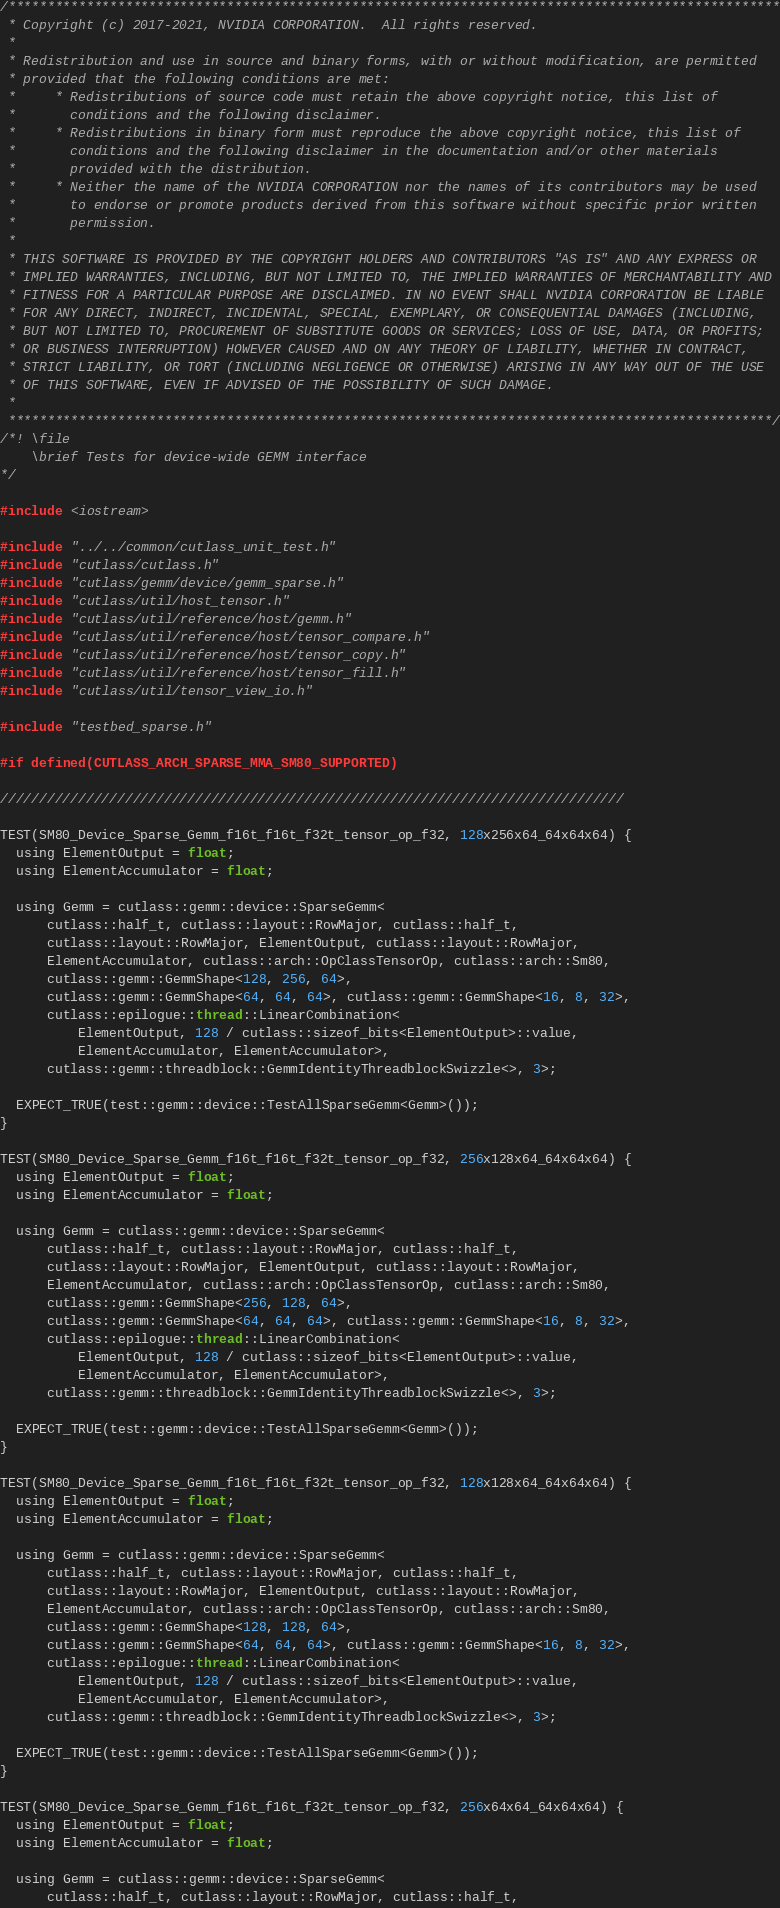Convert code to text. <code><loc_0><loc_0><loc_500><loc_500><_Cuda_>/***************************************************************************************************
 * Copyright (c) 2017-2021, NVIDIA CORPORATION.  All rights reserved.
 *
 * Redistribution and use in source and binary forms, with or without modification, are permitted
 * provided that the following conditions are met:
 *     * Redistributions of source code must retain the above copyright notice, this list of
 *       conditions and the following disclaimer.
 *     * Redistributions in binary form must reproduce the above copyright notice, this list of
 *       conditions and the following disclaimer in the documentation and/or other materials
 *       provided with the distribution.
 *     * Neither the name of the NVIDIA CORPORATION nor the names of its contributors may be used
 *       to endorse or promote products derived from this software without specific prior written
 *       permission.
 *
 * THIS SOFTWARE IS PROVIDED BY THE COPYRIGHT HOLDERS AND CONTRIBUTORS "AS IS" AND ANY EXPRESS OR
 * IMPLIED WARRANTIES, INCLUDING, BUT NOT LIMITED TO, THE IMPLIED WARRANTIES OF MERCHANTABILITY AND
 * FITNESS FOR A PARTICULAR PURPOSE ARE DISCLAIMED. IN NO EVENT SHALL NVIDIA CORPORATION BE LIABLE
 * FOR ANY DIRECT, INDIRECT, INCIDENTAL, SPECIAL, EXEMPLARY, OR CONSEQUENTIAL DAMAGES (INCLUDING,
 * BUT NOT LIMITED TO, PROCUREMENT OF SUBSTITUTE GOODS OR SERVICES; LOSS OF USE, DATA, OR PROFITS;
 * OR BUSINESS INTERRUPTION) HOWEVER CAUSED AND ON ANY THEORY OF LIABILITY, WHETHER IN CONTRACT,
 * STRICT LIABILITY, OR TORT (INCLUDING NEGLIGENCE OR OTHERWISE) ARISING IN ANY WAY OUT OF THE USE
 * OF THIS SOFTWARE, EVEN IF ADVISED OF THE POSSIBILITY OF SUCH DAMAGE.
 *
 **************************************************************************************************/
/*! \file
    \brief Tests for device-wide GEMM interface
*/

#include <iostream>

#include "../../common/cutlass_unit_test.h"
#include "cutlass/cutlass.h"
#include "cutlass/gemm/device/gemm_sparse.h"
#include "cutlass/util/host_tensor.h"
#include "cutlass/util/reference/host/gemm.h"
#include "cutlass/util/reference/host/tensor_compare.h"
#include "cutlass/util/reference/host/tensor_copy.h"
#include "cutlass/util/reference/host/tensor_fill.h"
#include "cutlass/util/tensor_view_io.h"

#include "testbed_sparse.h"

#if defined(CUTLASS_ARCH_SPARSE_MMA_SM80_SUPPORTED)

////////////////////////////////////////////////////////////////////////////////

TEST(SM80_Device_Sparse_Gemm_f16t_f16t_f32t_tensor_op_f32, 128x256x64_64x64x64) {
  using ElementOutput = float;
  using ElementAccumulator = float;

  using Gemm = cutlass::gemm::device::SparseGemm<
      cutlass::half_t, cutlass::layout::RowMajor, cutlass::half_t,
      cutlass::layout::RowMajor, ElementOutput, cutlass::layout::RowMajor,
      ElementAccumulator, cutlass::arch::OpClassTensorOp, cutlass::arch::Sm80,
      cutlass::gemm::GemmShape<128, 256, 64>,
      cutlass::gemm::GemmShape<64, 64, 64>, cutlass::gemm::GemmShape<16, 8, 32>,
      cutlass::epilogue::thread::LinearCombination<
          ElementOutput, 128 / cutlass::sizeof_bits<ElementOutput>::value,
          ElementAccumulator, ElementAccumulator>,
      cutlass::gemm::threadblock::GemmIdentityThreadblockSwizzle<>, 3>;

  EXPECT_TRUE(test::gemm::device::TestAllSparseGemm<Gemm>());
}

TEST(SM80_Device_Sparse_Gemm_f16t_f16t_f32t_tensor_op_f32, 256x128x64_64x64x64) {
  using ElementOutput = float;
  using ElementAccumulator = float;

  using Gemm = cutlass::gemm::device::SparseGemm<
      cutlass::half_t, cutlass::layout::RowMajor, cutlass::half_t,
      cutlass::layout::RowMajor, ElementOutput, cutlass::layout::RowMajor,
      ElementAccumulator, cutlass::arch::OpClassTensorOp, cutlass::arch::Sm80,
      cutlass::gemm::GemmShape<256, 128, 64>,
      cutlass::gemm::GemmShape<64, 64, 64>, cutlass::gemm::GemmShape<16, 8, 32>,
      cutlass::epilogue::thread::LinearCombination<
          ElementOutput, 128 / cutlass::sizeof_bits<ElementOutput>::value,
          ElementAccumulator, ElementAccumulator>,
      cutlass::gemm::threadblock::GemmIdentityThreadblockSwizzle<>, 3>;

  EXPECT_TRUE(test::gemm::device::TestAllSparseGemm<Gemm>());
}

TEST(SM80_Device_Sparse_Gemm_f16t_f16t_f32t_tensor_op_f32, 128x128x64_64x64x64) {
  using ElementOutput = float;
  using ElementAccumulator = float;

  using Gemm = cutlass::gemm::device::SparseGemm<
      cutlass::half_t, cutlass::layout::RowMajor, cutlass::half_t,
      cutlass::layout::RowMajor, ElementOutput, cutlass::layout::RowMajor,
      ElementAccumulator, cutlass::arch::OpClassTensorOp, cutlass::arch::Sm80,
      cutlass::gemm::GemmShape<128, 128, 64>,
      cutlass::gemm::GemmShape<64, 64, 64>, cutlass::gemm::GemmShape<16, 8, 32>,
      cutlass::epilogue::thread::LinearCombination<
          ElementOutput, 128 / cutlass::sizeof_bits<ElementOutput>::value,
          ElementAccumulator, ElementAccumulator>,
      cutlass::gemm::threadblock::GemmIdentityThreadblockSwizzle<>, 3>;

  EXPECT_TRUE(test::gemm::device::TestAllSparseGemm<Gemm>());
}

TEST(SM80_Device_Sparse_Gemm_f16t_f16t_f32t_tensor_op_f32, 256x64x64_64x64x64) {
  using ElementOutput = float;
  using ElementAccumulator = float;

  using Gemm = cutlass::gemm::device::SparseGemm<
      cutlass::half_t, cutlass::layout::RowMajor, cutlass::half_t,</code> 